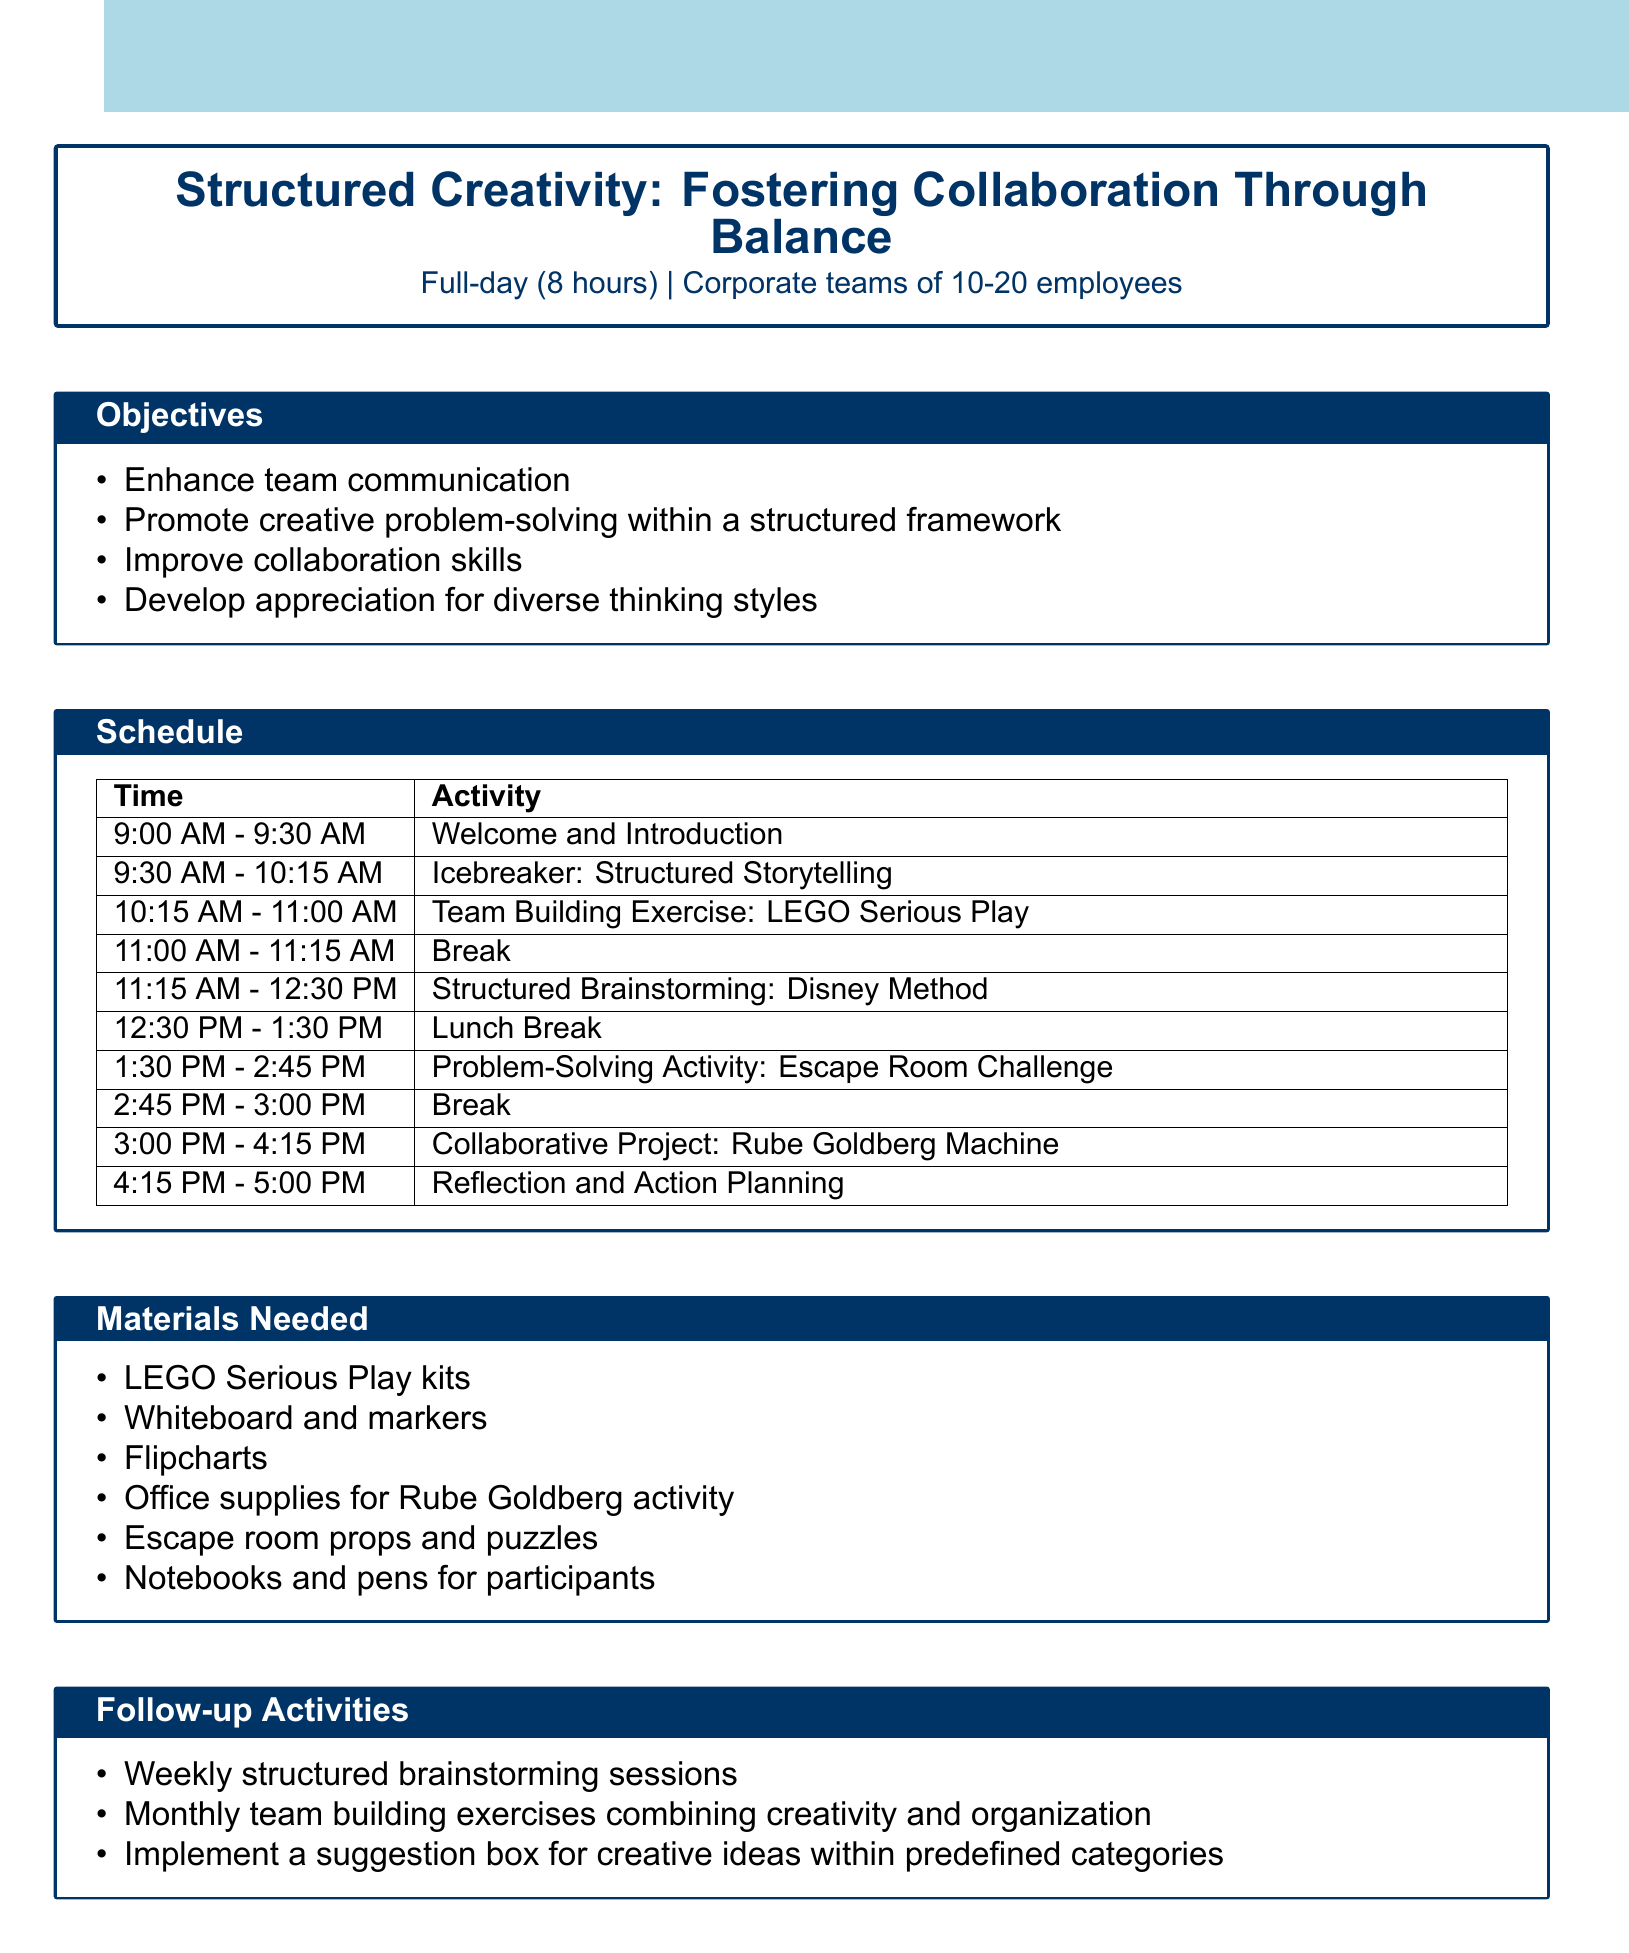What is the workshop title? The workshop title is provided at the beginning of the document as the main focus of the agenda.
Answer: Structured Creativity: Fostering Collaboration Through Balance What is the duration of the workshop? The duration is specified in the introductory section of the document.
Answer: Full-day (8 hours) What is the target audience? The document mentions the intended participants for the workshop explicitly in the introductory section.
Answer: Corporate teams of 10-20 employees What activity is scheduled at 11:15 AM? This question requires locating the specific time and corresponding activity mentioned in the schedule section of the document.
Answer: Structured Brainstorming: Disney Method What materials are needed for the Rube Goldberg activity? The materials are listed in the section dedicated to what is required for each activity, allowing us to find specific items.
Answer: Office supplies for Rube Goldberg activity What is the main objective of the workshop? The main objectives are listed in the objective section of the document requiring an understanding of the goals set for the workshop.
Answer: Enhance team communication How will the workshop address creativity? This requires reasoning through the information about how structured activities promote creativity, as mentioned in multiple sections of the document.
Answer: Structured Brainstorming and LEGO Serious Play What is one recommended follow-up activity? The follow-up activities are explicitly listed towards the end of the document; this requires recalling information from that section.
Answer: Weekly structured brainstorming sessions What type of exercise is the Icebreaker? The document specifies the nature of each exercise in the schedule section, allowing us to determine their type and structure.
Answer: Structured Storytelling 